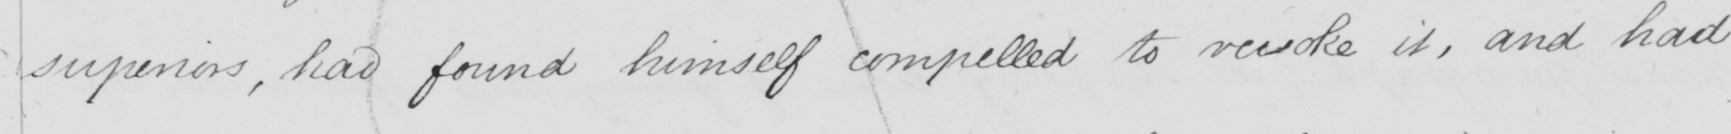Can you tell me what this handwritten text says? superiors , have found himself compelled to revoke it , and had 